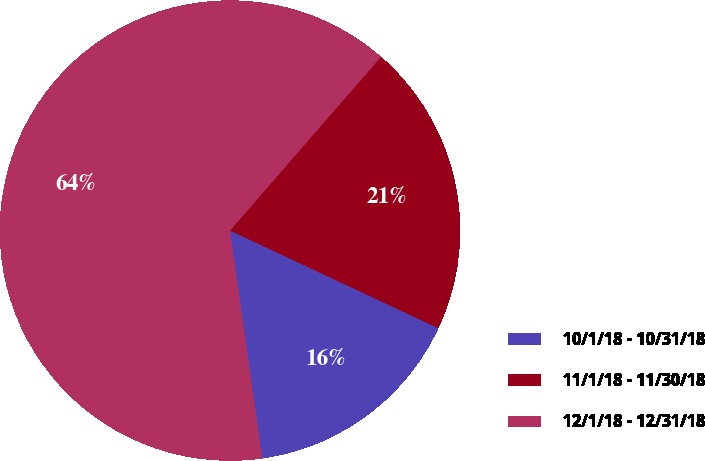Convert chart. <chart><loc_0><loc_0><loc_500><loc_500><pie_chart><fcel>10/1/18 - 10/31/18<fcel>11/1/18 - 11/30/18<fcel>12/1/18 - 12/31/18<nl><fcel>15.79%<fcel>20.58%<fcel>63.63%<nl></chart> 